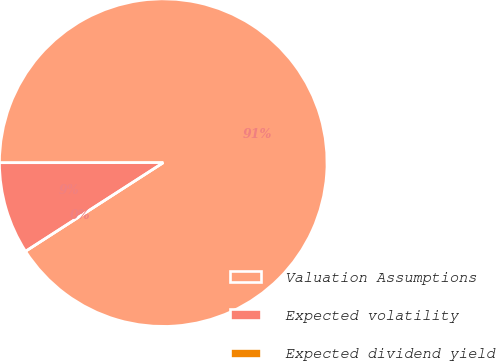Convert chart. <chart><loc_0><loc_0><loc_500><loc_500><pie_chart><fcel>Valuation Assumptions<fcel>Expected volatility<fcel>Expected dividend yield<nl><fcel>90.9%<fcel>9.09%<fcel>0.0%<nl></chart> 